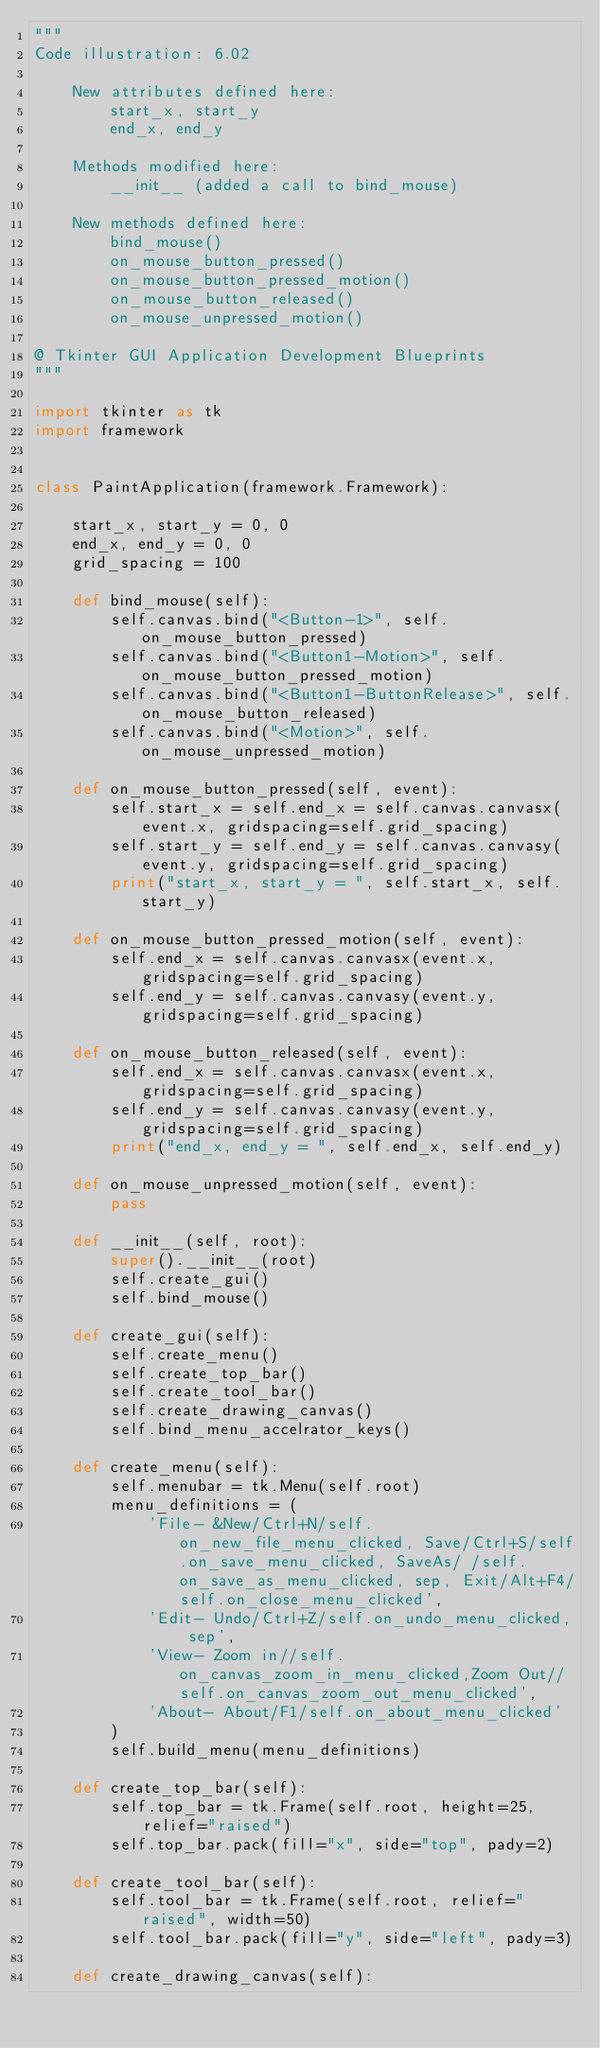Convert code to text. <code><loc_0><loc_0><loc_500><loc_500><_Python_>"""
Code illustration: 6.02

    New attributes defined here:
        start_x, start_y
        end_x, end_y

    Methods modified here:
        __init__ (added a call to bind_mouse)
    
    New methods defined here:
        bind_mouse()
        on_mouse_button_pressed()
        on_mouse_button_pressed_motion()
        on_mouse_button_released()
        on_mouse_unpressed_motion()

@ Tkinter GUI Application Development Blueprints
"""

import tkinter as tk
import framework


class PaintApplication(framework.Framework):

    start_x, start_y = 0, 0
    end_x, end_y = 0, 0
    grid_spacing = 100

    def bind_mouse(self):
        self.canvas.bind("<Button-1>", self.on_mouse_button_pressed)
        self.canvas.bind("<Button1-Motion>", self.on_mouse_button_pressed_motion)
        self.canvas.bind("<Button1-ButtonRelease>", self.on_mouse_button_released)
        self.canvas.bind("<Motion>", self.on_mouse_unpressed_motion)

    def on_mouse_button_pressed(self, event):
        self.start_x = self.end_x = self.canvas.canvasx(event.x, gridspacing=self.grid_spacing) 
        self.start_y = self.end_y = self.canvas.canvasy(event.y, gridspacing=self.grid_spacing)
        print("start_x, start_y = ", self.start_x, self.start_y)

    def on_mouse_button_pressed_motion(self, event):
        self.end_x = self.canvas.canvasx(event.x, gridspacing=self.grid_spacing)
        self.end_y = self.canvas.canvasy(event.y, gridspacing=self.grid_spacing)

    def on_mouse_button_released(self, event):
        self.end_x = self.canvas.canvasx(event.x, gridspacing=self.grid_spacing)
        self.end_y = self.canvas.canvasy(event.y, gridspacing=self.grid_spacing)
        print("end_x, end_y = ", self.end_x, self.end_y)

    def on_mouse_unpressed_motion(self, event):
        pass

    def __init__(self, root):
        super().__init__(root)
        self.create_gui()
        self.bind_mouse()

    def create_gui(self):
        self.create_menu()
        self.create_top_bar()
        self.create_tool_bar()
        self.create_drawing_canvas()
        self.bind_menu_accelrator_keys()

    def create_menu(self):
        self.menubar = tk.Menu(self.root)
        menu_definitions = (
            'File- &New/Ctrl+N/self.on_new_file_menu_clicked, Save/Ctrl+S/self.on_save_menu_clicked, SaveAs/ /self.on_save_as_menu_clicked, sep, Exit/Alt+F4/self.on_close_menu_clicked',
            'Edit- Undo/Ctrl+Z/self.on_undo_menu_clicked, sep',
            'View- Zoom in//self.on_canvas_zoom_in_menu_clicked,Zoom Out//self.on_canvas_zoom_out_menu_clicked',
            'About- About/F1/self.on_about_menu_clicked'
        )
        self.build_menu(menu_definitions)

    def create_top_bar(self):
        self.top_bar = tk.Frame(self.root, height=25, relief="raised")
        self.top_bar.pack(fill="x", side="top", pady=2)

    def create_tool_bar(self):
        self.tool_bar = tk.Frame(self.root, relief="raised", width=50)
        self.tool_bar.pack(fill="y", side="left", pady=3)

    def create_drawing_canvas(self):</code> 